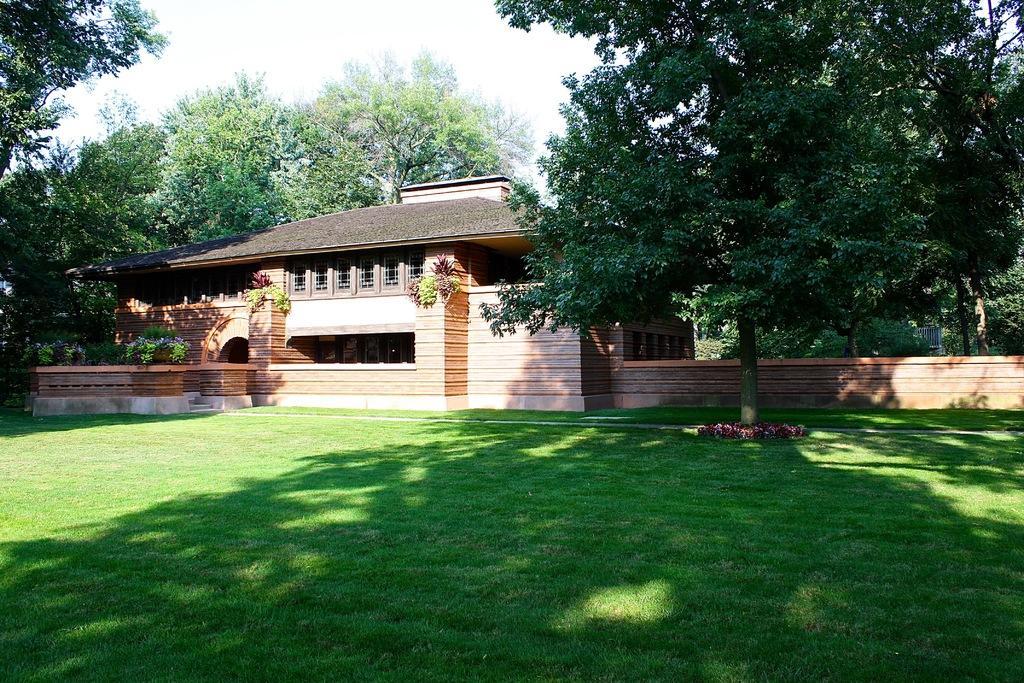Please provide a concise description of this image. In the image there is a house and around the house there are many trees and there is a garden in front of the house. 